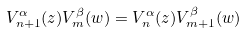<formula> <loc_0><loc_0><loc_500><loc_500>V _ { n + 1 } ^ { \alpha } ( z ) V _ { m } ^ { \beta } ( w ) = V _ { n } ^ { \alpha } ( z ) V _ { m + 1 } ^ { \beta } ( w )</formula> 